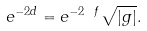Convert formula to latex. <formula><loc_0><loc_0><loc_500><loc_500>e ^ { - 2 d } = e ^ { - 2 \ f } \sqrt { | g | } .</formula> 